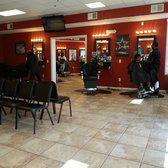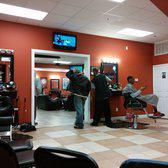The first image is the image on the left, the second image is the image on the right. Analyze the images presented: Is the assertion "You can see there is a TV hanging on the wall in at least one of the images." valid? Answer yes or no. Yes. 